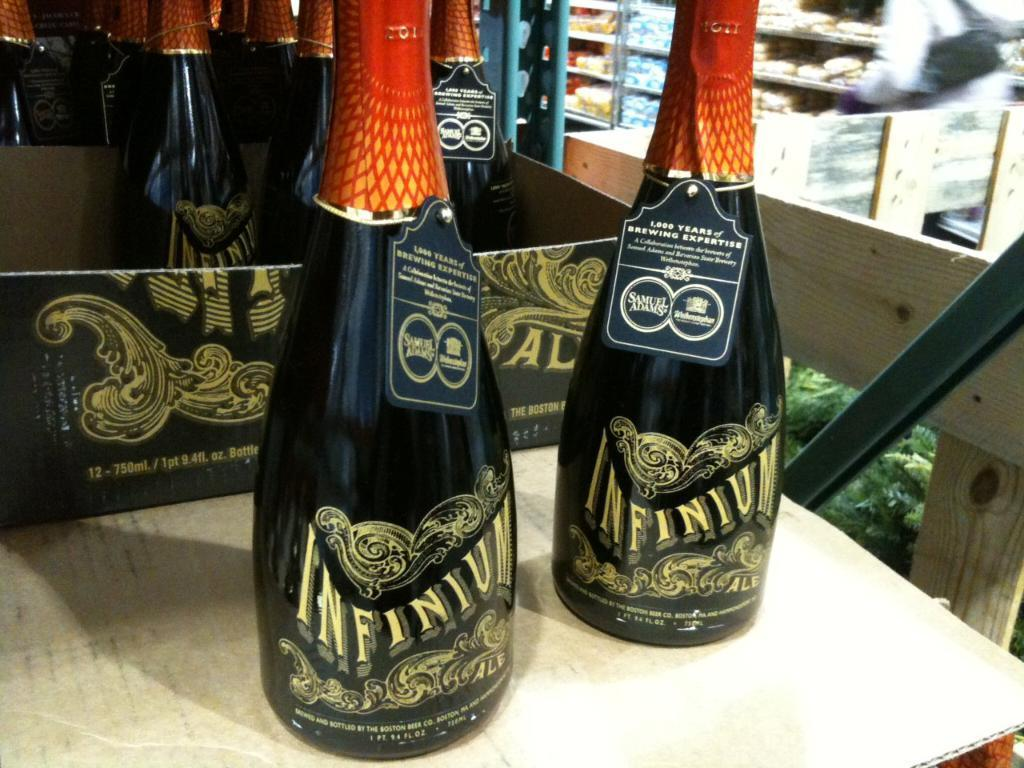<image>
Offer a succinct explanation of the picture presented. Two bottles of Infinium Ale stand on a table. 